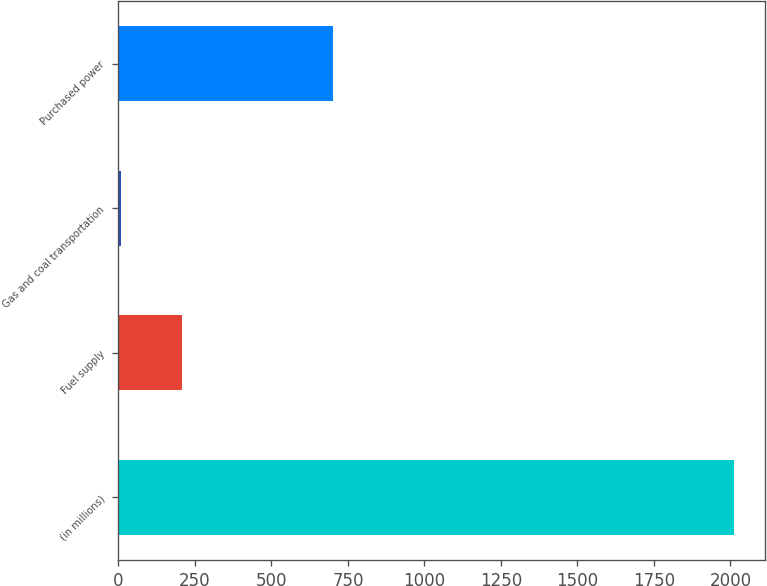<chart> <loc_0><loc_0><loc_500><loc_500><bar_chart><fcel>(in millions)<fcel>Fuel supply<fcel>Gas and coal transportation<fcel>Purchased power<nl><fcel>2013<fcel>209.4<fcel>9<fcel>702<nl></chart> 